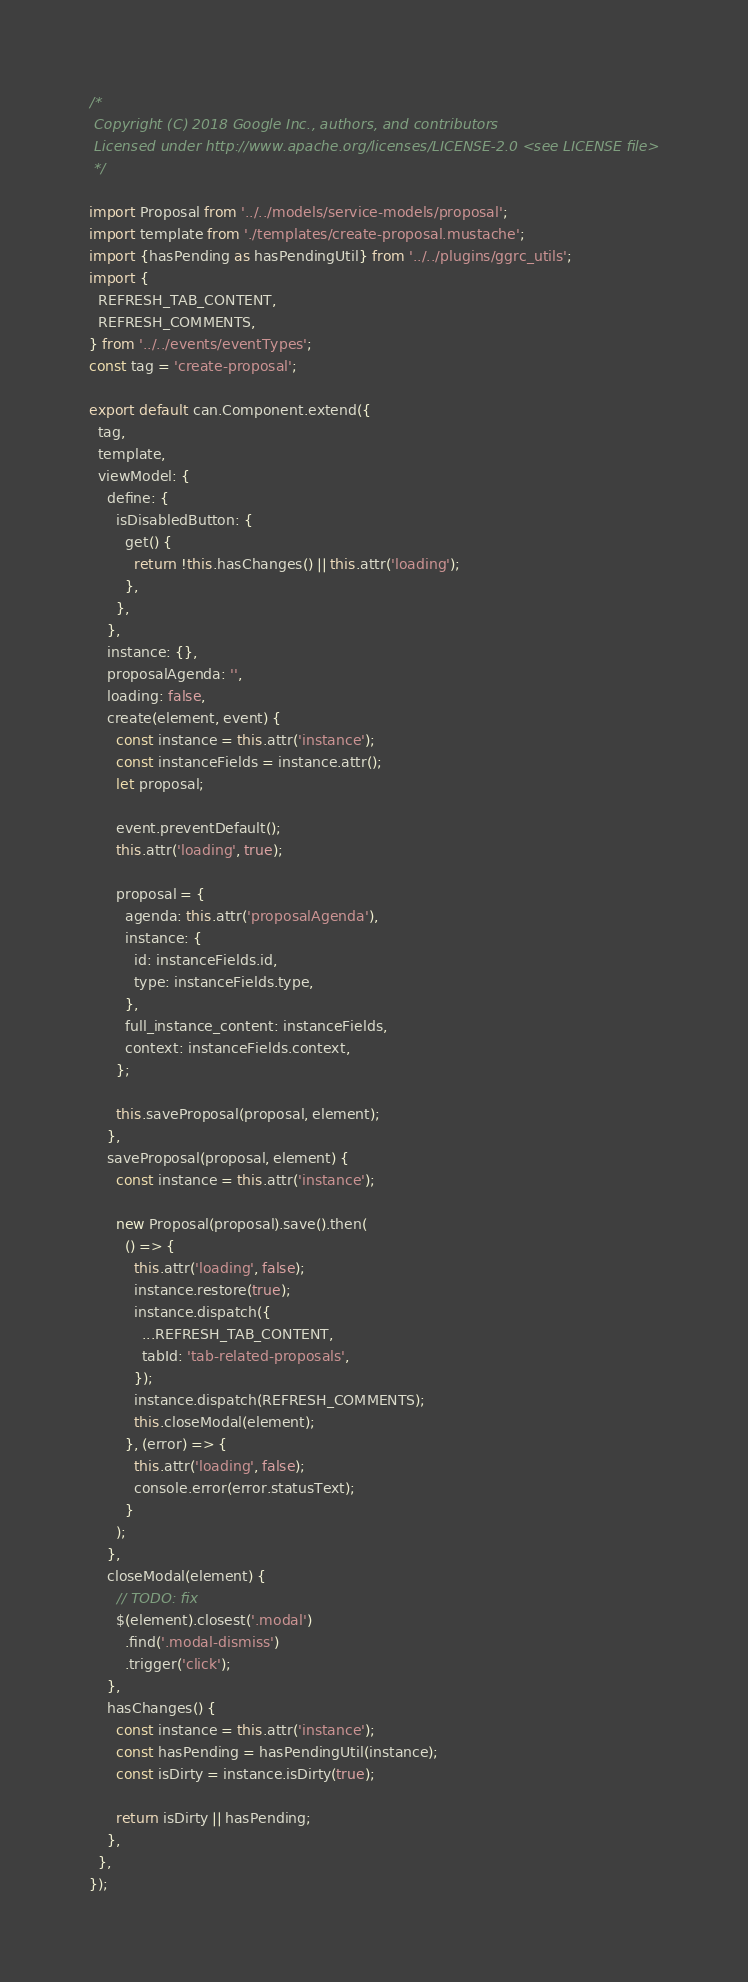Convert code to text. <code><loc_0><loc_0><loc_500><loc_500><_JavaScript_>/*
 Copyright (C) 2018 Google Inc., authors, and contributors
 Licensed under http://www.apache.org/licenses/LICENSE-2.0 <see LICENSE file>
 */

import Proposal from '../../models/service-models/proposal';
import template from './templates/create-proposal.mustache';
import {hasPending as hasPendingUtil} from '../../plugins/ggrc_utils';
import {
  REFRESH_TAB_CONTENT,
  REFRESH_COMMENTS,
} from '../../events/eventTypes';
const tag = 'create-proposal';

export default can.Component.extend({
  tag,
  template,
  viewModel: {
    define: {
      isDisabledButton: {
        get() {
          return !this.hasChanges() || this.attr('loading');
        },
      },
    },
    instance: {},
    proposalAgenda: '',
    loading: false,
    create(element, event) {
      const instance = this.attr('instance');
      const instanceFields = instance.attr();
      let proposal;

      event.preventDefault();
      this.attr('loading', true);

      proposal = {
        agenda: this.attr('proposalAgenda'),
        instance: {
          id: instanceFields.id,
          type: instanceFields.type,
        },
        full_instance_content: instanceFields,
        context: instanceFields.context,
      };

      this.saveProposal(proposal, element);
    },
    saveProposal(proposal, element) {
      const instance = this.attr('instance');

      new Proposal(proposal).save().then(
        () => {
          this.attr('loading', false);
          instance.restore(true);
          instance.dispatch({
            ...REFRESH_TAB_CONTENT,
            tabId: 'tab-related-proposals',
          });
          instance.dispatch(REFRESH_COMMENTS);
          this.closeModal(element);
        }, (error) => {
          this.attr('loading', false);
          console.error(error.statusText);
        }
      );
    },
    closeModal(element) {
      // TODO: fix
      $(element).closest('.modal')
        .find('.modal-dismiss')
        .trigger('click');
    },
    hasChanges() {
      const instance = this.attr('instance');
      const hasPending = hasPendingUtil(instance);
      const isDirty = instance.isDirty(true);

      return isDirty || hasPending;
    },
  },
});
</code> 